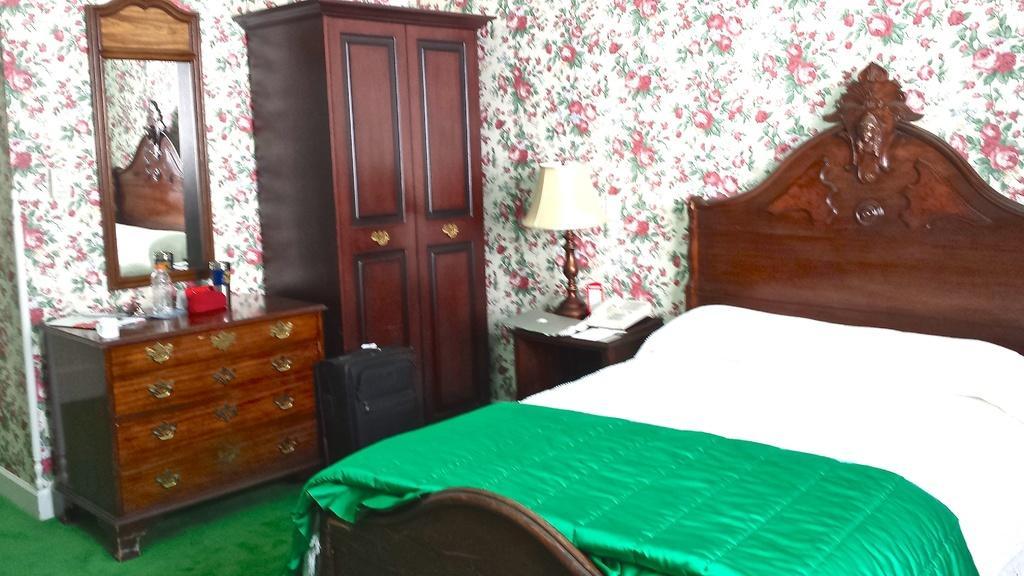In one or two sentences, can you explain what this image depicts? This is a picture of the inside of the house in this picture on the right side there is one bed and on the bed there is one blanket and on the top there is a wall and on the right side there is one cupboard. Beside that cupboard there is one table and one mirror is there on the table there is one bottle and some papers are there and beside the table there is one suitcase. 